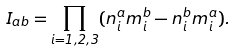<formula> <loc_0><loc_0><loc_500><loc_500>I _ { a b } = \prod _ { i = 1 , 2 , 3 } ( n ^ { a } _ { i } m ^ { b } _ { i } - n ^ { b } _ { i } m ^ { a } _ { i } ) .</formula> 